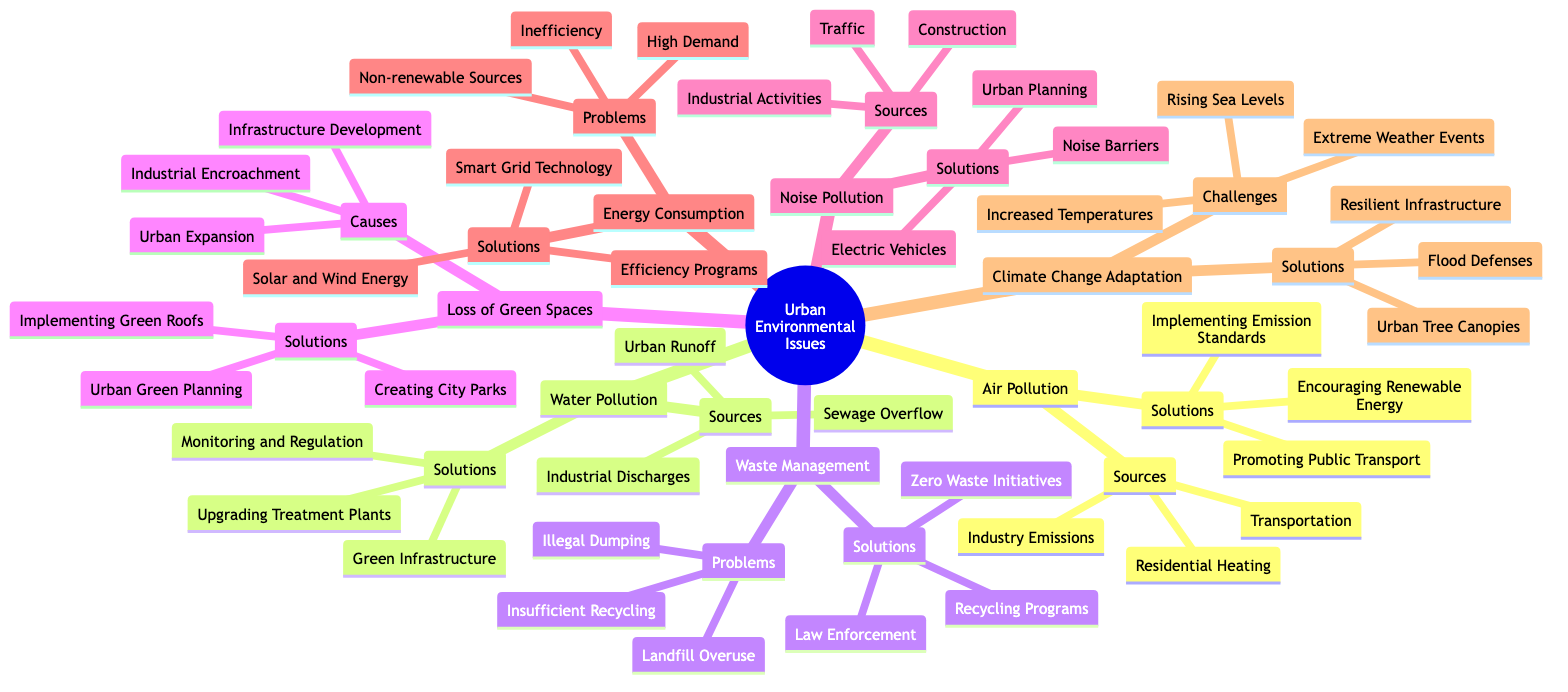What are the main sources of air pollution? The nodes under "Air Pollution" specify the sources: Transportation, Industry Emissions, and Residential Heating. By directly referring to those listed sources, we can identify them.
Answer: Transportation, Industry Emissions, Residential Heating How many solutions are listed for water pollution? Under the "Water Pollution" section, there are three solutions provided: Upgrading Wastewater Treatment Plants, Implementing Green Infrastructure, and Monitoring and Regulation. Counting these entries gives the total.
Answer: 3 What is the primary challenge regarding climate change adaptation? The "Climate Change Adaptation" section lists challenges, with the main ones being: Increased Temperatures, Extreme Weather Events, and Rising Sea Levels. By noting these entries, we can determine the primary challenges.
Answer: Increased Temperatures, Extreme Weather Events, Rising Sea Levels What are two causes of the loss of green spaces? The "Loss of Green Spaces" section identifies three causes: Urban Expansion, Infrastructure Development, and Industrial Encroachment. Selecting any two of these causes answers the question.
Answer: Urban Expansion, Infrastructure Development Name one solution for noise pollution. Looking at the "Noise Pollution" node, possible solutions are listed: Noise Barriers, Urban Planning, and Promoting Electric Vehicles. Any of these can sufficiently answer the question as a representative solution.
Answer: Noise Barriers What common problem is listed under waste management? The "Waste Management" section presents three problems: Insufficient Recycling, Landfill Overuse, and Illegal Dumping. Mentioning any one problem from this list addresses the inquiry.
Answer: Insufficient Recycling How are solutions for energy consumption categorized? Solutions for "Energy Consumption" include Energy Efficiency Programs, Smart Grid Technology, and Encouraging Solar and Wind Energy, noted as specific entries under that node. This categorization by solutions properly defines the methods to tackle the issue.
Answer: Energy Efficiency Programs, Smart Grid Technology, Encouraging Solar and Wind Energy What type of infrastructure is promoted for climate change adaptation? The solutions for "Climate Change Adaptation" include Urban Tree Canopies, Flood Defenses, and Climate-Resilient Infrastructure. The specific mention of "Climate-Resilient Infrastructure" directly answers the question posed.
Answer: Climate-Resilient Infrastructure 